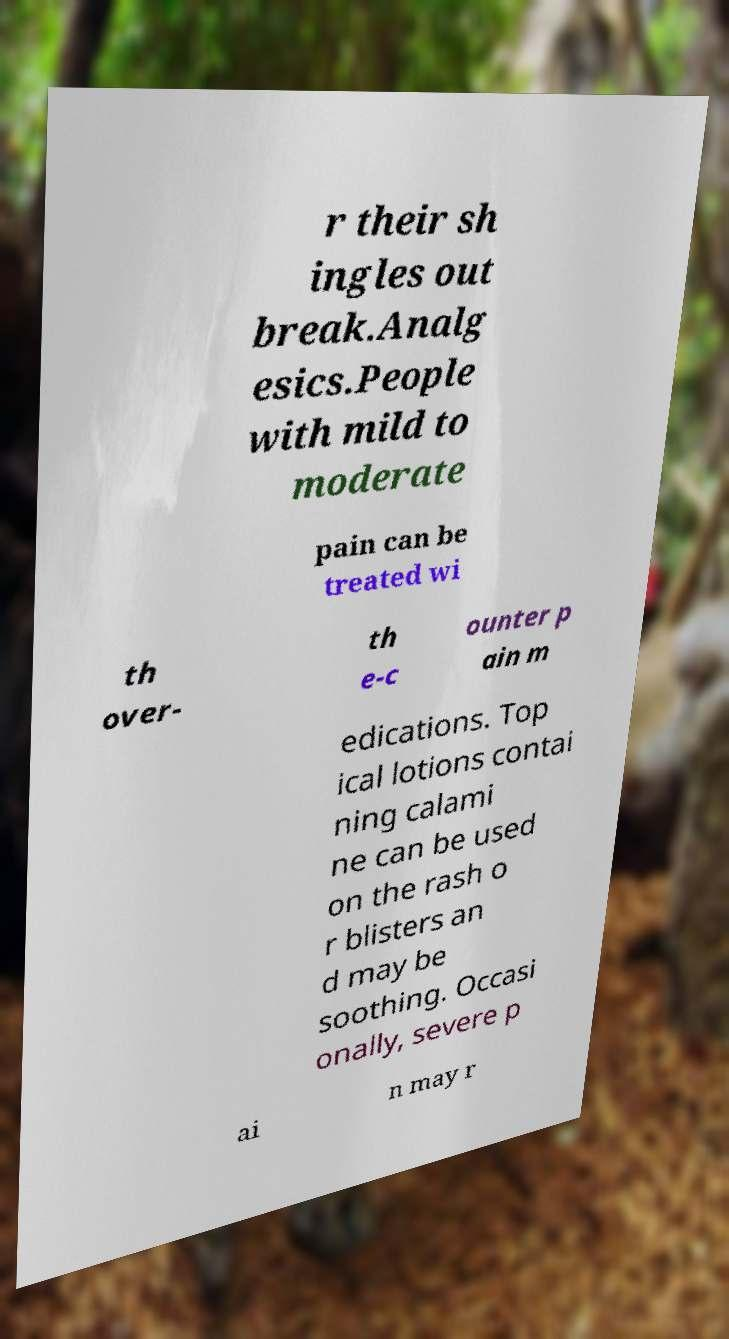For documentation purposes, I need the text within this image transcribed. Could you provide that? r their sh ingles out break.Analg esics.People with mild to moderate pain can be treated wi th over- th e-c ounter p ain m edications. Top ical lotions contai ning calami ne can be used on the rash o r blisters an d may be soothing. Occasi onally, severe p ai n may r 